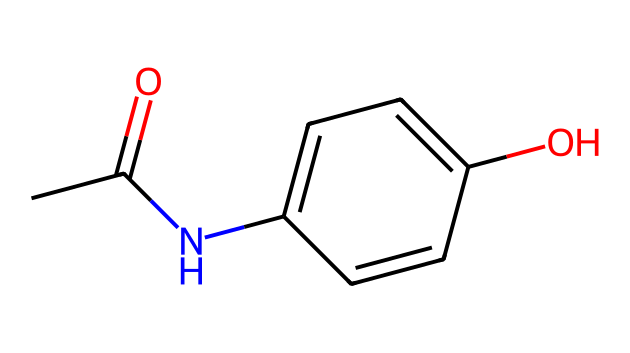What is the main functional group present in this chemical? The structure contains an amide functional group indicated by the CC(=O)N portion. The carbonyl (C=O) and nitrogen (N) create an amide.
Answer: amide How many carbon atoms are in this chemical? By counting the carbon atoms in the SMILES representation CC(=O)NC1=CC=C(O)C=C1, we find a total of 9 carbon atoms.
Answer: 9 What type of compound is represented by this chemical? The presence of the amide group and aromatic ring indicates that this compound is a drug.
Answer: drug How many double bonds are present in this molecule? Analyzing the structure reveals three double bonds: one in the carbonyl group, one in the aromatic ring, and another between the adjacent carbons in the aromatic system.
Answer: 3 What is the molecular weight of this chemical approximately? The molecular weight can be calculated by summing the atomic weights of all the atoms: 9 carbons, 9 hydrogens, 1 nitrogen, and 2 oxygens which totals around 165 grams/mol.
Answer: 165 Is this chemical likely to be soluble in water? Given the presence of the hydroxyl (O) group along with the aromatic characteristics and the amide group, this chemical suggests some degree of water solubility, although not very high.
Answer: moderately soluble 